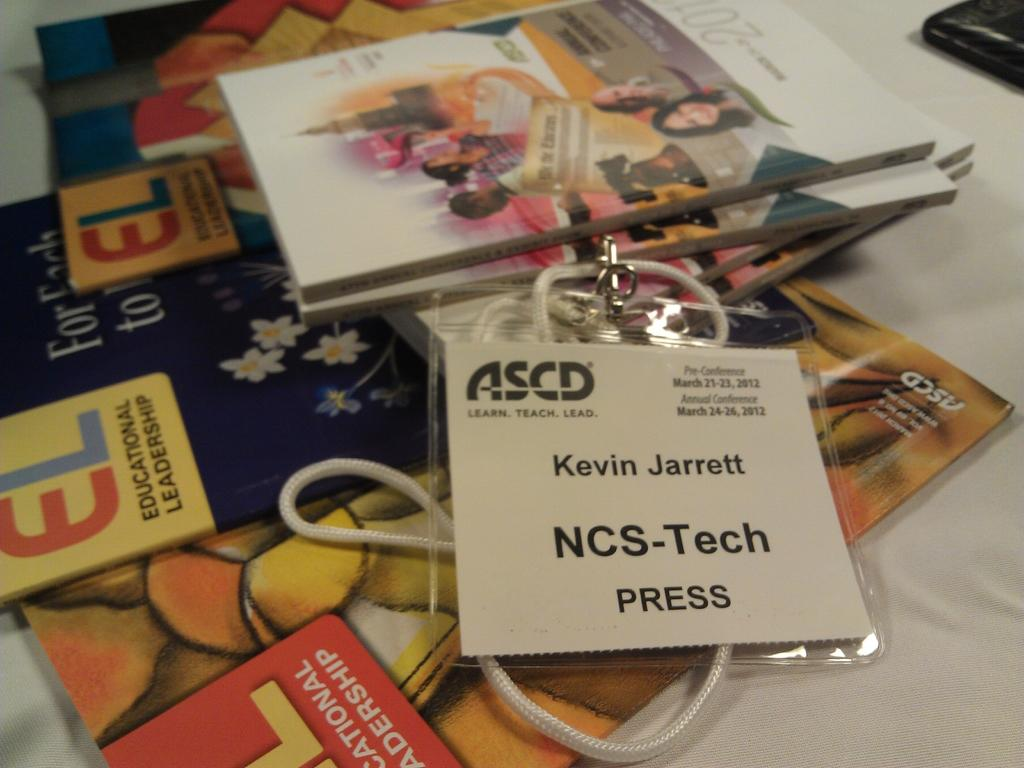Provide a one-sentence caption for the provided image. A white table with magazines and a press pass belonging to NCS-Tech Kevin Jarrett. 